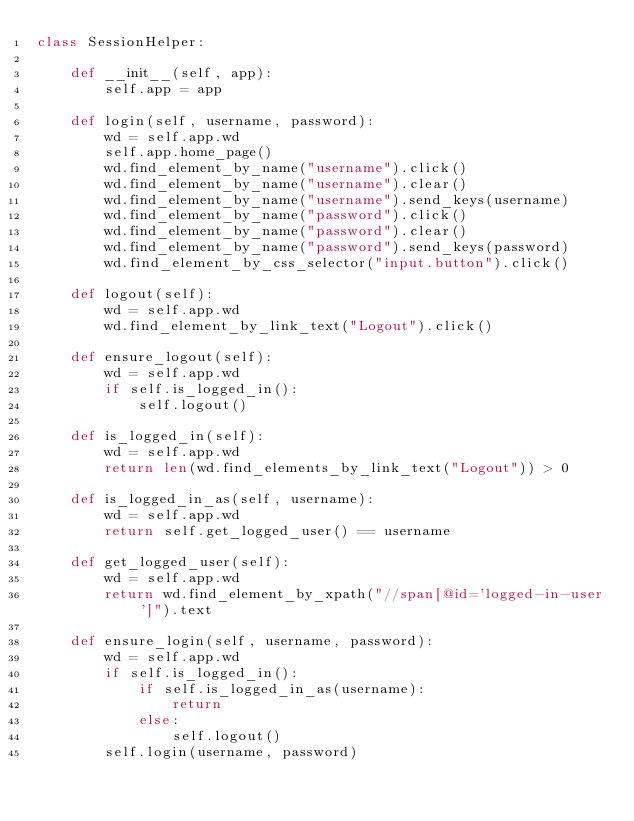<code> <loc_0><loc_0><loc_500><loc_500><_Python_>class SessionHelper:

    def __init__(self, app):
        self.app = app

    def login(self, username, password):
        wd = self.app.wd
        self.app.home_page()
        wd.find_element_by_name("username").click()
        wd.find_element_by_name("username").clear()
        wd.find_element_by_name("username").send_keys(username)
        wd.find_element_by_name("password").click()
        wd.find_element_by_name("password").clear()
        wd.find_element_by_name("password").send_keys(password)
        wd.find_element_by_css_selector("input.button").click()

    def logout(self):
        wd = self.app.wd
        wd.find_element_by_link_text("Logout").click()

    def ensure_logout(self):
        wd = self.app.wd
        if self.is_logged_in():
            self.logout()

    def is_logged_in(self):
        wd = self.app.wd
        return len(wd.find_elements_by_link_text("Logout")) > 0

    def is_logged_in_as(self, username):
        wd = self.app.wd
        return self.get_logged_user() == username

    def get_logged_user(self):
        wd = self.app.wd
        return wd.find_element_by_xpath("//span[@id='logged-in-user']").text

    def ensure_login(self, username, password):
        wd = self.app.wd
        if self.is_logged_in():
            if self.is_logged_in_as(username):
                return
            else:
                self.logout()
        self.login(username, password)

</code> 